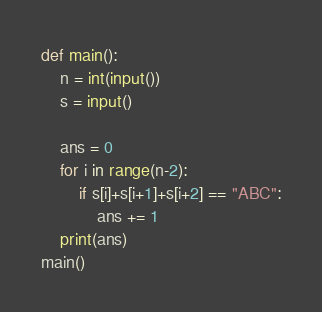Convert code to text. <code><loc_0><loc_0><loc_500><loc_500><_Python_>def main():
    n = int(input())
    s = input()

    ans = 0
    for i in range(n-2):
        if s[i]+s[i+1]+s[i+2] == "ABC":
            ans += 1
    print(ans)
main()</code> 